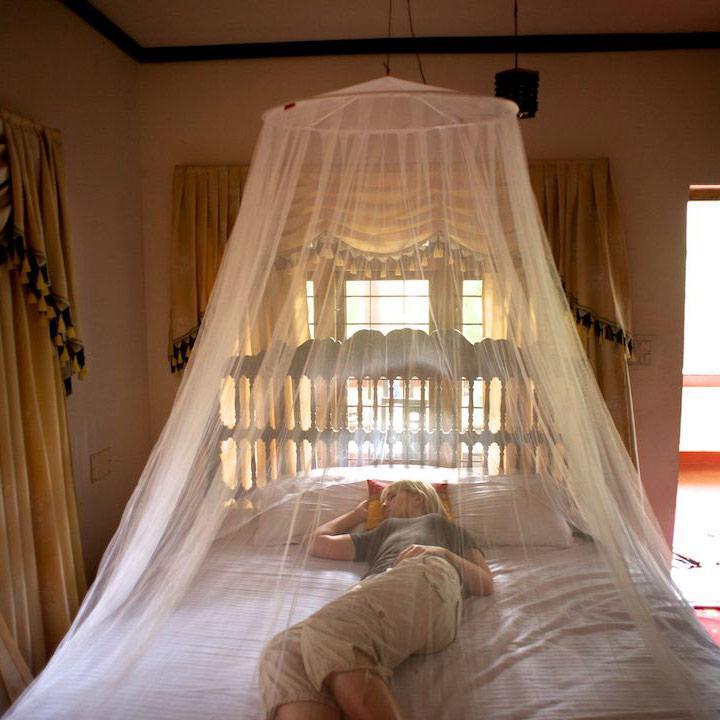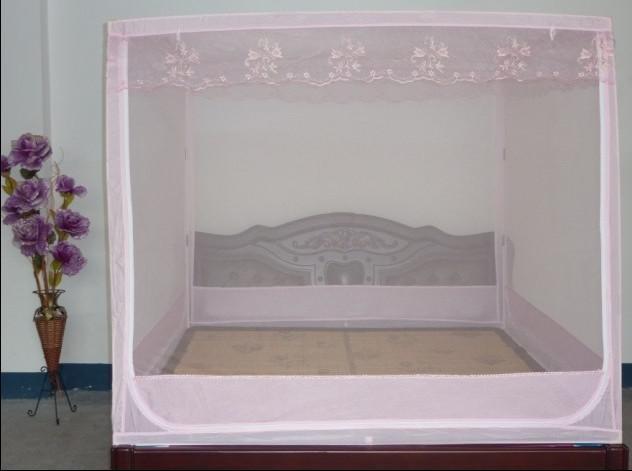The first image is the image on the left, the second image is the image on the right. Evaluate the accuracy of this statement regarding the images: "The canopy bed in the left image is by a window showing daylight outside.". Is it true? Answer yes or no. Yes. 